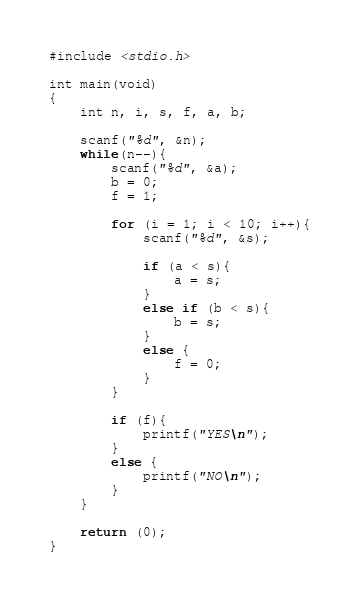<code> <loc_0><loc_0><loc_500><loc_500><_C_>#include <stdio.h>

int main(void)
{
	int n, i, s, f, a, b;
	
	scanf("%d", &n);
	while(n--){
		scanf("%d", &a);
		b = 0;
		f = 1;
		
		for (i = 1; i < 10; i++){
			scanf("%d", &s);
			
			if (a < s){
				a = s;
			}
			else if (b < s){
				b = s;
			}
			else {
				f = 0;
			}
		}
		
		if (f){
			printf("YES\n");
		}
		else {
			printf("NO\n");
		}
	}
	
	return (0);
}</code> 